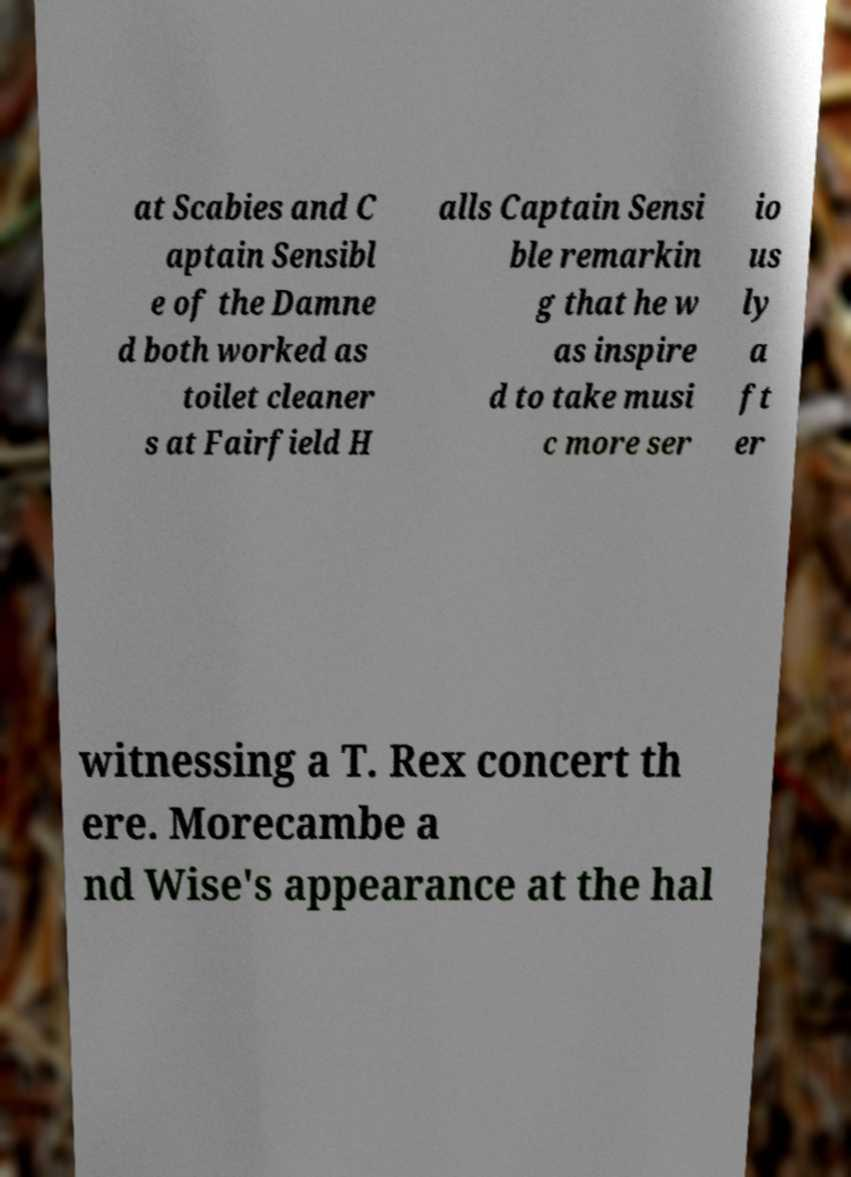Can you read and provide the text displayed in the image?This photo seems to have some interesting text. Can you extract and type it out for me? at Scabies and C aptain Sensibl e of the Damne d both worked as toilet cleaner s at Fairfield H alls Captain Sensi ble remarkin g that he w as inspire d to take musi c more ser io us ly a ft er witnessing a T. Rex concert th ere. Morecambe a nd Wise's appearance at the hal 